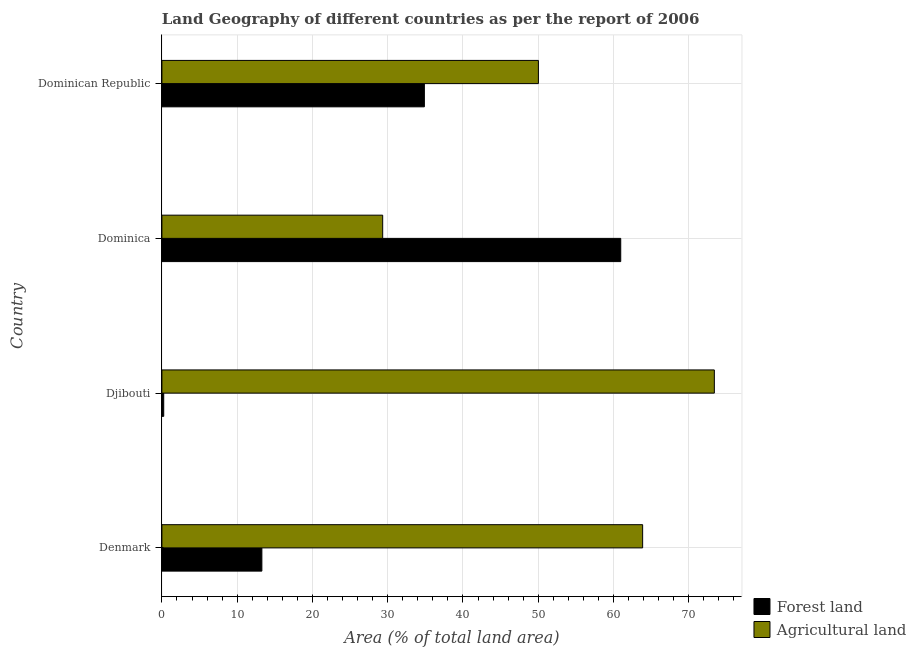What is the label of the 4th group of bars from the top?
Ensure brevity in your answer.  Denmark. In how many cases, is the number of bars for a given country not equal to the number of legend labels?
Ensure brevity in your answer.  0. What is the percentage of land area under forests in Denmark?
Offer a very short reply. 13.28. Across all countries, what is the maximum percentage of land area under agriculture?
Your response must be concise. 73.4. Across all countries, what is the minimum percentage of land area under agriculture?
Your response must be concise. 29.33. In which country was the percentage of land area under forests maximum?
Give a very brief answer. Dominica. In which country was the percentage of land area under agriculture minimum?
Make the answer very short. Dominica. What is the total percentage of land area under agriculture in the graph?
Ensure brevity in your answer.  216.62. What is the difference between the percentage of land area under forests in Denmark and that in Dominican Republic?
Offer a terse response. -21.59. What is the difference between the percentage of land area under agriculture in Dominican Republic and the percentage of land area under forests in Djibouti?
Your answer should be very brief. 49.78. What is the average percentage of land area under forests per country?
Provide a succinct answer. 27.34. What is the difference between the percentage of land area under forests and percentage of land area under agriculture in Djibouti?
Offer a terse response. -73.15. In how many countries, is the percentage of land area under agriculture greater than 38 %?
Offer a very short reply. 3. What is the ratio of the percentage of land area under forests in Denmark to that in Dominican Republic?
Provide a succinct answer. 0.38. Is the percentage of land area under agriculture in Djibouti less than that in Dominican Republic?
Ensure brevity in your answer.  No. Is the difference between the percentage of land area under forests in Dominica and Dominican Republic greater than the difference between the percentage of land area under agriculture in Dominica and Dominican Republic?
Ensure brevity in your answer.  Yes. What is the difference between the highest and the second highest percentage of land area under agriculture?
Offer a terse response. 9.53. What is the difference between the highest and the lowest percentage of land area under forests?
Make the answer very short. 60.72. In how many countries, is the percentage of land area under agriculture greater than the average percentage of land area under agriculture taken over all countries?
Keep it short and to the point. 2. Is the sum of the percentage of land area under forests in Denmark and Djibouti greater than the maximum percentage of land area under agriculture across all countries?
Your response must be concise. No. What does the 1st bar from the top in Denmark represents?
Offer a very short reply. Agricultural land. What does the 2nd bar from the bottom in Dominican Republic represents?
Your answer should be compact. Agricultural land. Are all the bars in the graph horizontal?
Keep it short and to the point. Yes. Are the values on the major ticks of X-axis written in scientific E-notation?
Keep it short and to the point. No. Does the graph contain grids?
Make the answer very short. Yes. How many legend labels are there?
Make the answer very short. 2. What is the title of the graph?
Keep it short and to the point. Land Geography of different countries as per the report of 2006. Does "Borrowers" appear as one of the legend labels in the graph?
Provide a succinct answer. No. What is the label or title of the X-axis?
Keep it short and to the point. Area (% of total land area). What is the Area (% of total land area) in Forest land in Denmark?
Make the answer very short. 13.28. What is the Area (% of total land area) of Agricultural land in Denmark?
Ensure brevity in your answer.  63.87. What is the Area (% of total land area) in Forest land in Djibouti?
Make the answer very short. 0.24. What is the Area (% of total land area) in Agricultural land in Djibouti?
Provide a short and direct response. 73.4. What is the Area (% of total land area) of Forest land in Dominica?
Offer a very short reply. 60.96. What is the Area (% of total land area) in Agricultural land in Dominica?
Provide a short and direct response. 29.33. What is the Area (% of total land area) in Forest land in Dominican Republic?
Keep it short and to the point. 34.87. What is the Area (% of total land area) of Agricultural land in Dominican Republic?
Keep it short and to the point. 50.02. Across all countries, what is the maximum Area (% of total land area) of Forest land?
Your answer should be very brief. 60.96. Across all countries, what is the maximum Area (% of total land area) in Agricultural land?
Make the answer very short. 73.4. Across all countries, what is the minimum Area (% of total land area) of Forest land?
Your answer should be very brief. 0.24. Across all countries, what is the minimum Area (% of total land area) in Agricultural land?
Provide a succinct answer. 29.33. What is the total Area (% of total land area) in Forest land in the graph?
Keep it short and to the point. 109.36. What is the total Area (% of total land area) of Agricultural land in the graph?
Your response must be concise. 216.62. What is the difference between the Area (% of total land area) in Forest land in Denmark and that in Djibouti?
Provide a short and direct response. 13.04. What is the difference between the Area (% of total land area) in Agricultural land in Denmark and that in Djibouti?
Give a very brief answer. -9.53. What is the difference between the Area (% of total land area) in Forest land in Denmark and that in Dominica?
Provide a short and direct response. -47.68. What is the difference between the Area (% of total land area) of Agricultural land in Denmark and that in Dominica?
Provide a short and direct response. 34.54. What is the difference between the Area (% of total land area) in Forest land in Denmark and that in Dominican Republic?
Offer a very short reply. -21.59. What is the difference between the Area (% of total land area) of Agricultural land in Denmark and that in Dominican Republic?
Provide a succinct answer. 13.85. What is the difference between the Area (% of total land area) in Forest land in Djibouti and that in Dominica?
Your response must be concise. -60.72. What is the difference between the Area (% of total land area) of Agricultural land in Djibouti and that in Dominica?
Your answer should be very brief. 44.06. What is the difference between the Area (% of total land area) of Forest land in Djibouti and that in Dominican Republic?
Provide a short and direct response. -34.63. What is the difference between the Area (% of total land area) of Agricultural land in Djibouti and that in Dominican Republic?
Give a very brief answer. 23.37. What is the difference between the Area (% of total land area) in Forest land in Dominica and that in Dominican Republic?
Offer a terse response. 26.09. What is the difference between the Area (% of total land area) of Agricultural land in Dominica and that in Dominican Republic?
Provide a short and direct response. -20.69. What is the difference between the Area (% of total land area) of Forest land in Denmark and the Area (% of total land area) of Agricultural land in Djibouti?
Provide a succinct answer. -60.11. What is the difference between the Area (% of total land area) of Forest land in Denmark and the Area (% of total land area) of Agricultural land in Dominica?
Make the answer very short. -16.05. What is the difference between the Area (% of total land area) in Forest land in Denmark and the Area (% of total land area) in Agricultural land in Dominican Republic?
Your answer should be compact. -36.74. What is the difference between the Area (% of total land area) of Forest land in Djibouti and the Area (% of total land area) of Agricultural land in Dominica?
Give a very brief answer. -29.09. What is the difference between the Area (% of total land area) in Forest land in Djibouti and the Area (% of total land area) in Agricultural land in Dominican Republic?
Ensure brevity in your answer.  -49.78. What is the difference between the Area (% of total land area) of Forest land in Dominica and the Area (% of total land area) of Agricultural land in Dominican Republic?
Offer a very short reply. 10.94. What is the average Area (% of total land area) in Forest land per country?
Your response must be concise. 27.34. What is the average Area (% of total land area) in Agricultural land per country?
Make the answer very short. 54.15. What is the difference between the Area (% of total land area) in Forest land and Area (% of total land area) in Agricultural land in Denmark?
Your answer should be very brief. -50.59. What is the difference between the Area (% of total land area) in Forest land and Area (% of total land area) in Agricultural land in Djibouti?
Ensure brevity in your answer.  -73.15. What is the difference between the Area (% of total land area) in Forest land and Area (% of total land area) in Agricultural land in Dominica?
Give a very brief answer. 31.63. What is the difference between the Area (% of total land area) of Forest land and Area (% of total land area) of Agricultural land in Dominican Republic?
Give a very brief answer. -15.15. What is the ratio of the Area (% of total land area) of Forest land in Denmark to that in Djibouti?
Your response must be concise. 54.98. What is the ratio of the Area (% of total land area) of Agricultural land in Denmark to that in Djibouti?
Offer a terse response. 0.87. What is the ratio of the Area (% of total land area) in Forest land in Denmark to that in Dominica?
Your response must be concise. 0.22. What is the ratio of the Area (% of total land area) in Agricultural land in Denmark to that in Dominica?
Give a very brief answer. 2.18. What is the ratio of the Area (% of total land area) in Forest land in Denmark to that in Dominican Republic?
Your response must be concise. 0.38. What is the ratio of the Area (% of total land area) of Agricultural land in Denmark to that in Dominican Republic?
Offer a terse response. 1.28. What is the ratio of the Area (% of total land area) of Forest land in Djibouti to that in Dominica?
Give a very brief answer. 0. What is the ratio of the Area (% of total land area) of Agricultural land in Djibouti to that in Dominica?
Make the answer very short. 2.5. What is the ratio of the Area (% of total land area) in Forest land in Djibouti to that in Dominican Republic?
Your answer should be very brief. 0.01. What is the ratio of the Area (% of total land area) of Agricultural land in Djibouti to that in Dominican Republic?
Keep it short and to the point. 1.47. What is the ratio of the Area (% of total land area) of Forest land in Dominica to that in Dominican Republic?
Provide a short and direct response. 1.75. What is the ratio of the Area (% of total land area) of Agricultural land in Dominica to that in Dominican Republic?
Your answer should be compact. 0.59. What is the difference between the highest and the second highest Area (% of total land area) in Forest land?
Your answer should be very brief. 26.09. What is the difference between the highest and the second highest Area (% of total land area) of Agricultural land?
Provide a succinct answer. 9.53. What is the difference between the highest and the lowest Area (% of total land area) in Forest land?
Give a very brief answer. 60.72. What is the difference between the highest and the lowest Area (% of total land area) in Agricultural land?
Provide a succinct answer. 44.06. 